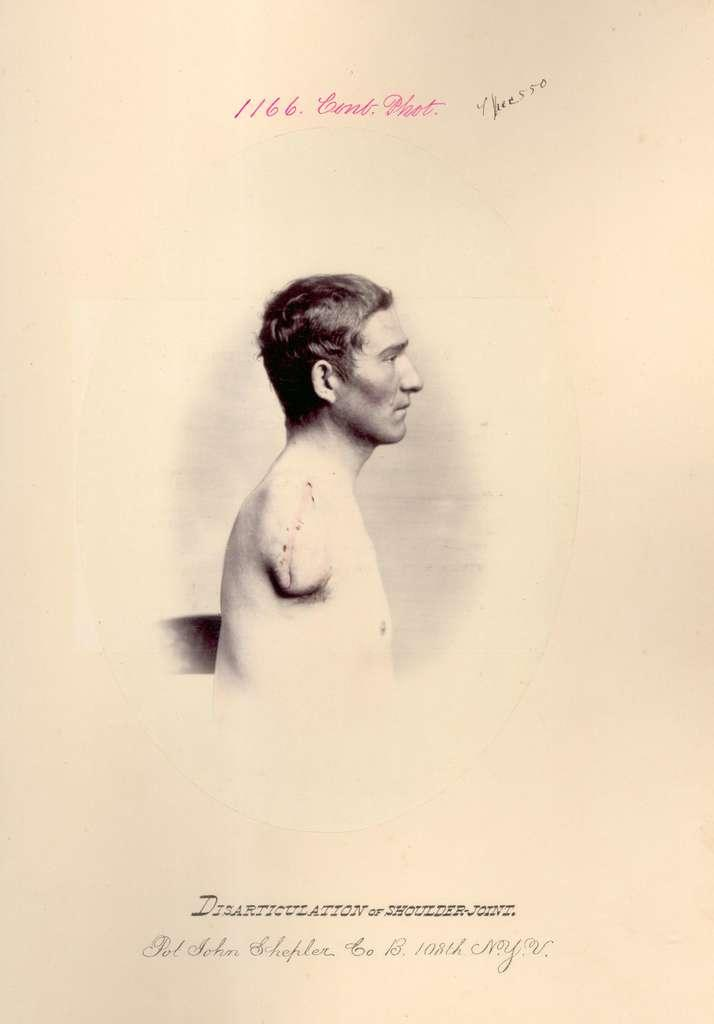What type of image is being described? The image is animated. Are there any words or phrases in the image? Yes, there is text in the image. What can be seen besides the text in the image? There is an image of a person in the image. Where is the cake located in the image? There is no cake present in the image. What type of wilderness can be seen in the image? There is no wilderness depicted in the image. 